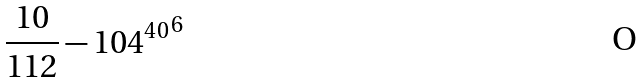<formula> <loc_0><loc_0><loc_500><loc_500>\frac { 1 0 } { 1 1 2 } - { 1 0 4 ^ { 4 0 } } ^ { 6 }</formula> 